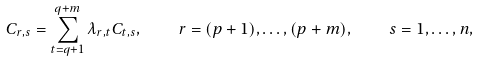Convert formula to latex. <formula><loc_0><loc_0><loc_500><loc_500>C _ { r , s } = \sum _ { t = q + 1 } ^ { q + m } \lambda _ { r , t } C _ { t , s } , \quad r = ( p + 1 ) , \dots , ( p + m ) , \quad s = 1 , \dots , n ,</formula> 